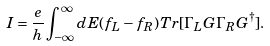Convert formula to latex. <formula><loc_0><loc_0><loc_500><loc_500>I = \frac { e } { h } \int _ { - \infty } ^ { \infty } d E ( f _ { L } - f _ { R } ) T r [ \Gamma _ { L } G \Gamma _ { R } G ^ { \dagger } ] .</formula> 